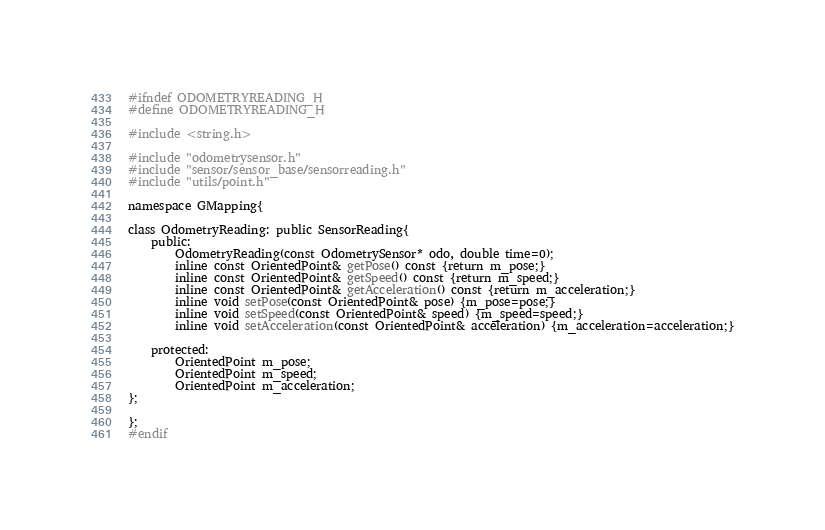<code> <loc_0><loc_0><loc_500><loc_500><_C_>#ifndef ODOMETRYREADING_H
#define ODOMETRYREADING_H

#include <string.h>

#include "odometrysensor.h"
#include "sensor/sensor_base/sensorreading.h"
#include "utils/point.h"

namespace GMapping{

class OdometryReading: public SensorReading{
	public:
		OdometryReading(const OdometrySensor* odo, double time=0);
		inline const OrientedPoint& getPose() const {return m_pose;}
		inline const OrientedPoint& getSpeed() const {return m_speed;}
		inline const OrientedPoint& getAcceleration() const {return m_acceleration;}
		inline void setPose(const OrientedPoint& pose) {m_pose=pose;}
		inline void setSpeed(const OrientedPoint& speed) {m_speed=speed;}
		inline void setAcceleration(const OrientedPoint& acceleration) {m_acceleration=acceleration;}

	protected:
		OrientedPoint m_pose;
		OrientedPoint m_speed;
		OrientedPoint m_acceleration;
};

};
#endif

</code> 